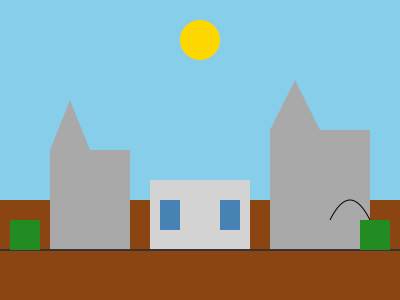In the city landscape diagram, identify the primary source of water pollution based on the visible elements. What specific type of pollution is most likely to originate from this source? To identify the primary source of water pollution in this city landscape, let's analyze the elements step by step:

1. The diagram shows a simplified city landscape with buildings, roads, and natural elements.

2. We can see two tall buildings (grey rectangles with triangular roofs) representing urban structures.

3. In the center, there's a smaller, lighter-colored rectangle with blue squares, likely representing a commercial or industrial facility.

4. A curved black line near the right building suggests a road or highway.

5. At the bottom of the image, there's a brown rectangle representing the ground, with a darker line potentially indicating a water body (river or coastline).

6. The commercial/industrial facility is positioned closest to this water line.

7. Industrial and commercial facilities are often significant sources of water pollution due to their operations and waste discharge.

8. The most common type of pollution from such facilities is often chemical pollution, which can include heavy metals, organic compounds, and other industrial byproducts.

Given these observations, the primary source of water pollution in this landscape is likely the commercial/industrial facility in the center. The specific type of pollution most likely to originate from this source is chemical pollution.
Answer: Chemical pollution from the commercial/industrial facility 